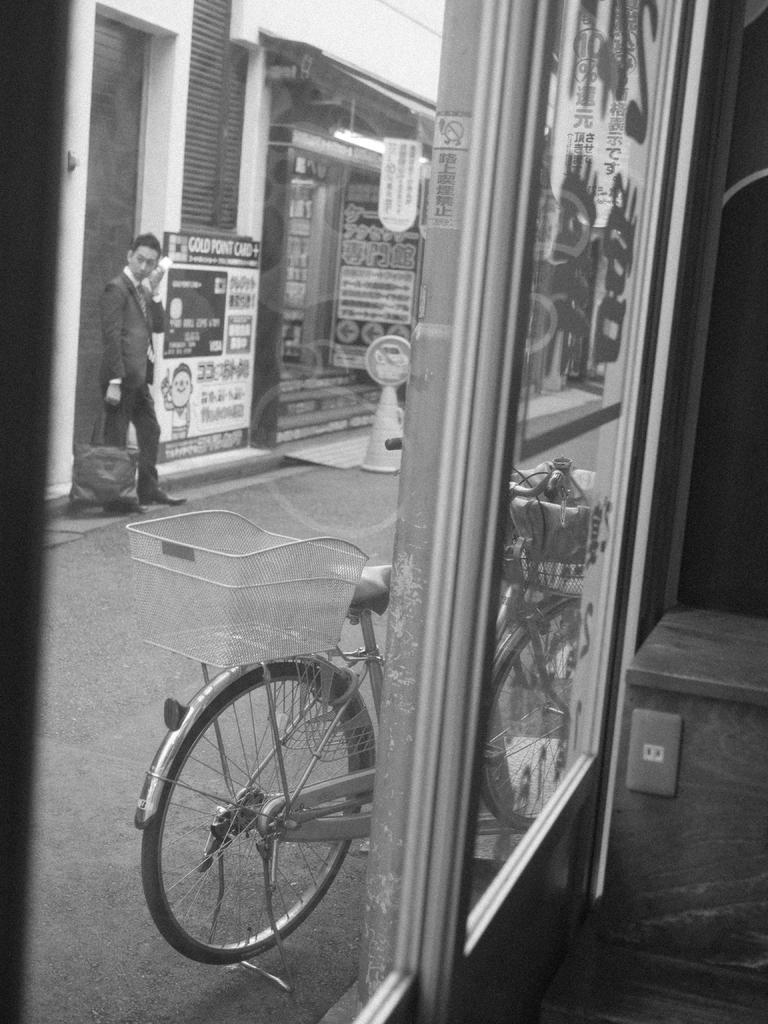Describe this image in one or two sentences. This is a black and white image and it is an inside view. On the right side, I can see a table which is placed on the floor. On the left side, I can see the glass through which we can see the outside view. In the outside, I can see a man standing on the road by holding a bag in the hand and also I can see a bicycle. In the background there is a building and few posters are attached to the walls. 